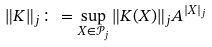<formula> <loc_0><loc_0><loc_500><loc_500>\| K \| _ { j } \colon = \sup _ { X \in \mathcal { P } _ { j } } \| K ( X ) \| _ { j } A ^ { | X | _ { j } }</formula> 